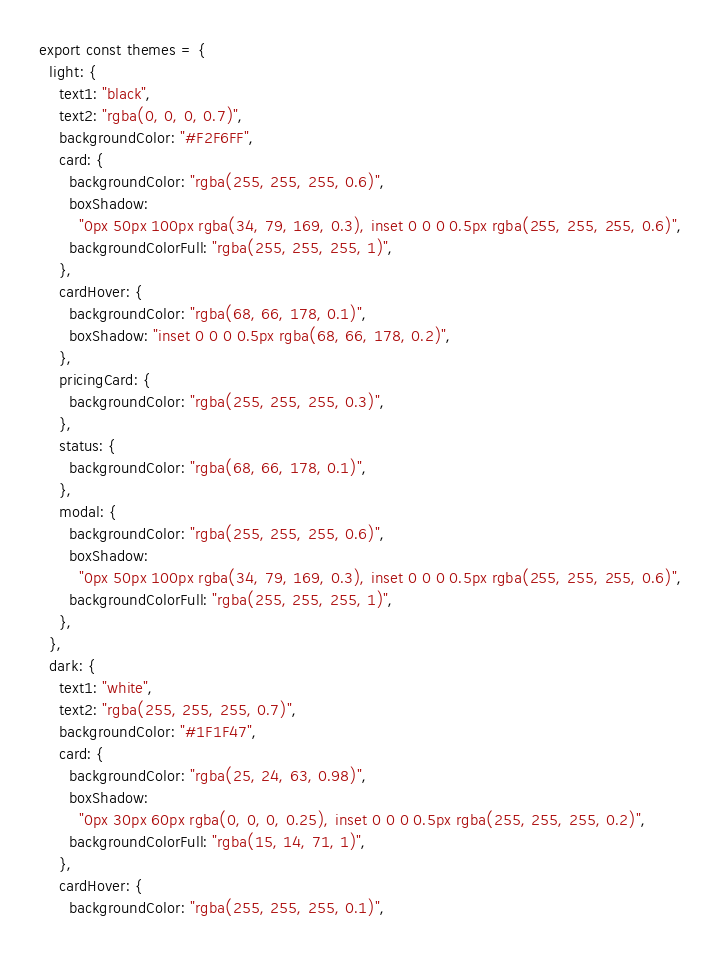<code> <loc_0><loc_0><loc_500><loc_500><_JavaScript_>export const themes = {
  light: {
    text1: "black",
    text2: "rgba(0, 0, 0, 0.7)",
    backgroundColor: "#F2F6FF",
    card: {
      backgroundColor: "rgba(255, 255, 255, 0.6)",
      boxShadow:
        "0px 50px 100px rgba(34, 79, 169, 0.3), inset 0 0 0 0.5px rgba(255, 255, 255, 0.6)",
      backgroundColorFull: "rgba(255, 255, 255, 1)",
    },
    cardHover: {
      backgroundColor: "rgba(68, 66, 178, 0.1)",
      boxShadow: "inset 0 0 0 0.5px rgba(68, 66, 178, 0.2)",
    },
    pricingCard: {
      backgroundColor: "rgba(255, 255, 255, 0.3)",
    },
    status: {
      backgroundColor: "rgba(68, 66, 178, 0.1)",
    },
    modal: {
      backgroundColor: "rgba(255, 255, 255, 0.6)",
      boxShadow:
        "0px 50px 100px rgba(34, 79, 169, 0.3), inset 0 0 0 0.5px rgba(255, 255, 255, 0.6)",
      backgroundColorFull: "rgba(255, 255, 255, 1)",
    },
  },
  dark: {
    text1: "white",
    text2: "rgba(255, 255, 255, 0.7)",
    backgroundColor: "#1F1F47",
    card: {
      backgroundColor: "rgba(25, 24, 63, 0.98)",
      boxShadow:
        "0px 30px 60px rgba(0, 0, 0, 0.25), inset 0 0 0 0.5px rgba(255, 255, 255, 0.2)",
      backgroundColorFull: "rgba(15, 14, 71, 1)",
    },
    cardHover: {
      backgroundColor: "rgba(255, 255, 255, 0.1)",</code> 